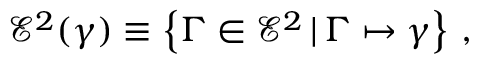Convert formula to latex. <formula><loc_0><loc_0><loc_500><loc_500>\mathcal { E } ^ { 2 } ( \gamma ) \equiv \left \{ \Gamma \in \mathcal { E } ^ { 2 } \, | \, \Gamma \mapsto \gamma \right \} \, ,</formula> 